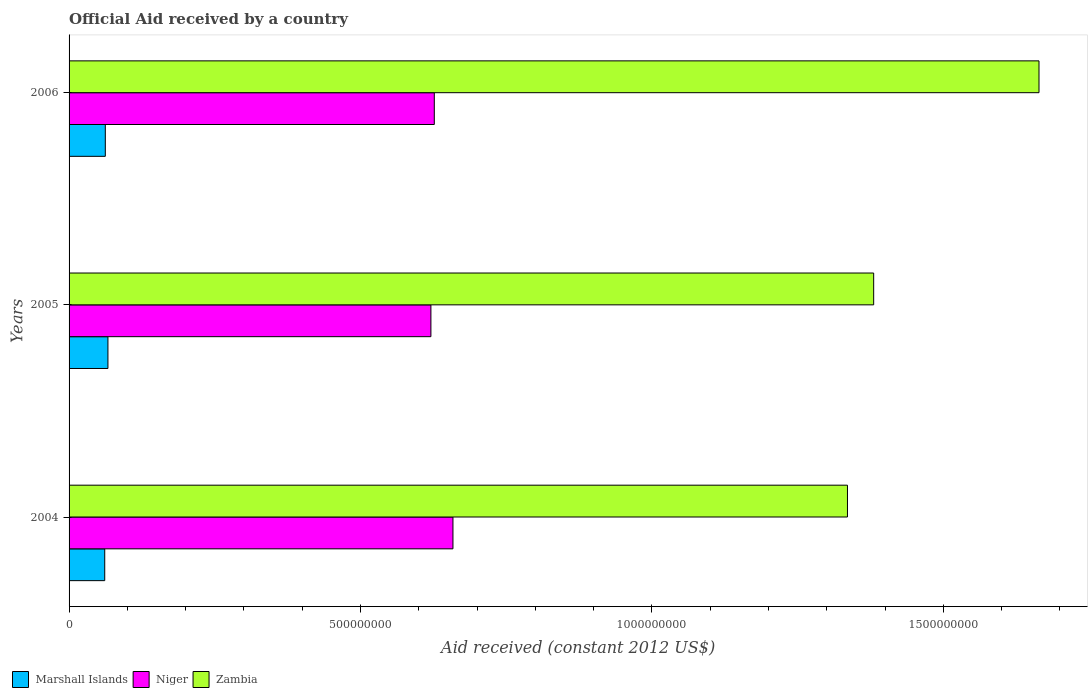How many different coloured bars are there?
Give a very brief answer. 3. How many bars are there on the 3rd tick from the top?
Provide a short and direct response. 3. How many bars are there on the 2nd tick from the bottom?
Your response must be concise. 3. What is the label of the 2nd group of bars from the top?
Make the answer very short. 2005. What is the net official aid received in Niger in 2006?
Give a very brief answer. 6.27e+08. Across all years, what is the maximum net official aid received in Marshall Islands?
Ensure brevity in your answer.  6.67e+07. Across all years, what is the minimum net official aid received in Zambia?
Give a very brief answer. 1.34e+09. In which year was the net official aid received in Niger maximum?
Make the answer very short. 2004. In which year was the net official aid received in Marshall Islands minimum?
Your response must be concise. 2004. What is the total net official aid received in Marshall Islands in the graph?
Ensure brevity in your answer.  1.90e+08. What is the difference between the net official aid received in Marshall Islands in 2004 and that in 2005?
Provide a short and direct response. -5.50e+06. What is the difference between the net official aid received in Zambia in 2004 and the net official aid received in Niger in 2005?
Ensure brevity in your answer.  7.15e+08. What is the average net official aid received in Zambia per year?
Give a very brief answer. 1.46e+09. In the year 2005, what is the difference between the net official aid received in Marshall Islands and net official aid received in Zambia?
Your answer should be very brief. -1.31e+09. What is the ratio of the net official aid received in Marshall Islands in 2004 to that in 2006?
Give a very brief answer. 0.98. Is the net official aid received in Marshall Islands in 2004 less than that in 2005?
Your response must be concise. Yes. Is the difference between the net official aid received in Marshall Islands in 2005 and 2006 greater than the difference between the net official aid received in Zambia in 2005 and 2006?
Offer a terse response. Yes. What is the difference between the highest and the second highest net official aid received in Marshall Islands?
Make the answer very short. 4.51e+06. What is the difference between the highest and the lowest net official aid received in Marshall Islands?
Provide a short and direct response. 5.50e+06. What does the 1st bar from the top in 2005 represents?
Offer a terse response. Zambia. What does the 2nd bar from the bottom in 2006 represents?
Your answer should be compact. Niger. Is it the case that in every year, the sum of the net official aid received in Niger and net official aid received in Zambia is greater than the net official aid received in Marshall Islands?
Keep it short and to the point. Yes. How many bars are there?
Ensure brevity in your answer.  9. How many years are there in the graph?
Give a very brief answer. 3. What is the difference between two consecutive major ticks on the X-axis?
Your response must be concise. 5.00e+08. Does the graph contain any zero values?
Give a very brief answer. No. How are the legend labels stacked?
Provide a short and direct response. Horizontal. What is the title of the graph?
Offer a very short reply. Official Aid received by a country. What is the label or title of the X-axis?
Your answer should be compact. Aid received (constant 2012 US$). What is the label or title of the Y-axis?
Provide a succinct answer. Years. What is the Aid received (constant 2012 US$) of Marshall Islands in 2004?
Provide a short and direct response. 6.12e+07. What is the Aid received (constant 2012 US$) of Niger in 2004?
Your answer should be very brief. 6.59e+08. What is the Aid received (constant 2012 US$) in Zambia in 2004?
Provide a succinct answer. 1.34e+09. What is the Aid received (constant 2012 US$) of Marshall Islands in 2005?
Your answer should be very brief. 6.67e+07. What is the Aid received (constant 2012 US$) in Niger in 2005?
Your response must be concise. 6.21e+08. What is the Aid received (constant 2012 US$) of Zambia in 2005?
Give a very brief answer. 1.38e+09. What is the Aid received (constant 2012 US$) in Marshall Islands in 2006?
Provide a succinct answer. 6.22e+07. What is the Aid received (constant 2012 US$) of Niger in 2006?
Make the answer very short. 6.27e+08. What is the Aid received (constant 2012 US$) in Zambia in 2006?
Provide a short and direct response. 1.66e+09. Across all years, what is the maximum Aid received (constant 2012 US$) in Marshall Islands?
Provide a succinct answer. 6.67e+07. Across all years, what is the maximum Aid received (constant 2012 US$) of Niger?
Your answer should be very brief. 6.59e+08. Across all years, what is the maximum Aid received (constant 2012 US$) in Zambia?
Provide a short and direct response. 1.66e+09. Across all years, what is the minimum Aid received (constant 2012 US$) of Marshall Islands?
Provide a short and direct response. 6.12e+07. Across all years, what is the minimum Aid received (constant 2012 US$) in Niger?
Give a very brief answer. 6.21e+08. Across all years, what is the minimum Aid received (constant 2012 US$) of Zambia?
Offer a terse response. 1.34e+09. What is the total Aid received (constant 2012 US$) in Marshall Islands in the graph?
Ensure brevity in your answer.  1.90e+08. What is the total Aid received (constant 2012 US$) in Niger in the graph?
Make the answer very short. 1.91e+09. What is the total Aid received (constant 2012 US$) of Zambia in the graph?
Provide a short and direct response. 4.38e+09. What is the difference between the Aid received (constant 2012 US$) of Marshall Islands in 2004 and that in 2005?
Your answer should be compact. -5.50e+06. What is the difference between the Aid received (constant 2012 US$) of Niger in 2004 and that in 2005?
Provide a short and direct response. 3.78e+07. What is the difference between the Aid received (constant 2012 US$) of Zambia in 2004 and that in 2005?
Your answer should be compact. -4.50e+07. What is the difference between the Aid received (constant 2012 US$) of Marshall Islands in 2004 and that in 2006?
Your answer should be compact. -9.90e+05. What is the difference between the Aid received (constant 2012 US$) in Niger in 2004 and that in 2006?
Your answer should be very brief. 3.20e+07. What is the difference between the Aid received (constant 2012 US$) in Zambia in 2004 and that in 2006?
Give a very brief answer. -3.29e+08. What is the difference between the Aid received (constant 2012 US$) of Marshall Islands in 2005 and that in 2006?
Offer a terse response. 4.51e+06. What is the difference between the Aid received (constant 2012 US$) of Niger in 2005 and that in 2006?
Provide a short and direct response. -5.81e+06. What is the difference between the Aid received (constant 2012 US$) of Zambia in 2005 and that in 2006?
Offer a terse response. -2.84e+08. What is the difference between the Aid received (constant 2012 US$) of Marshall Islands in 2004 and the Aid received (constant 2012 US$) of Niger in 2005?
Your response must be concise. -5.60e+08. What is the difference between the Aid received (constant 2012 US$) in Marshall Islands in 2004 and the Aid received (constant 2012 US$) in Zambia in 2005?
Keep it short and to the point. -1.32e+09. What is the difference between the Aid received (constant 2012 US$) of Niger in 2004 and the Aid received (constant 2012 US$) of Zambia in 2005?
Make the answer very short. -7.22e+08. What is the difference between the Aid received (constant 2012 US$) in Marshall Islands in 2004 and the Aid received (constant 2012 US$) in Niger in 2006?
Your response must be concise. -5.65e+08. What is the difference between the Aid received (constant 2012 US$) in Marshall Islands in 2004 and the Aid received (constant 2012 US$) in Zambia in 2006?
Provide a short and direct response. -1.60e+09. What is the difference between the Aid received (constant 2012 US$) of Niger in 2004 and the Aid received (constant 2012 US$) of Zambia in 2006?
Make the answer very short. -1.01e+09. What is the difference between the Aid received (constant 2012 US$) in Marshall Islands in 2005 and the Aid received (constant 2012 US$) in Niger in 2006?
Your response must be concise. -5.60e+08. What is the difference between the Aid received (constant 2012 US$) of Marshall Islands in 2005 and the Aid received (constant 2012 US$) of Zambia in 2006?
Your answer should be very brief. -1.60e+09. What is the difference between the Aid received (constant 2012 US$) of Niger in 2005 and the Aid received (constant 2012 US$) of Zambia in 2006?
Provide a short and direct response. -1.04e+09. What is the average Aid received (constant 2012 US$) in Marshall Islands per year?
Give a very brief answer. 6.34e+07. What is the average Aid received (constant 2012 US$) of Niger per year?
Keep it short and to the point. 6.35e+08. What is the average Aid received (constant 2012 US$) of Zambia per year?
Give a very brief answer. 1.46e+09. In the year 2004, what is the difference between the Aid received (constant 2012 US$) in Marshall Islands and Aid received (constant 2012 US$) in Niger?
Provide a short and direct response. -5.97e+08. In the year 2004, what is the difference between the Aid received (constant 2012 US$) in Marshall Islands and Aid received (constant 2012 US$) in Zambia?
Offer a terse response. -1.27e+09. In the year 2004, what is the difference between the Aid received (constant 2012 US$) of Niger and Aid received (constant 2012 US$) of Zambia?
Ensure brevity in your answer.  -6.77e+08. In the year 2005, what is the difference between the Aid received (constant 2012 US$) of Marshall Islands and Aid received (constant 2012 US$) of Niger?
Offer a very short reply. -5.54e+08. In the year 2005, what is the difference between the Aid received (constant 2012 US$) in Marshall Islands and Aid received (constant 2012 US$) in Zambia?
Give a very brief answer. -1.31e+09. In the year 2005, what is the difference between the Aid received (constant 2012 US$) of Niger and Aid received (constant 2012 US$) of Zambia?
Your answer should be very brief. -7.60e+08. In the year 2006, what is the difference between the Aid received (constant 2012 US$) in Marshall Islands and Aid received (constant 2012 US$) in Niger?
Give a very brief answer. -5.64e+08. In the year 2006, what is the difference between the Aid received (constant 2012 US$) of Marshall Islands and Aid received (constant 2012 US$) of Zambia?
Offer a very short reply. -1.60e+09. In the year 2006, what is the difference between the Aid received (constant 2012 US$) in Niger and Aid received (constant 2012 US$) in Zambia?
Your answer should be very brief. -1.04e+09. What is the ratio of the Aid received (constant 2012 US$) in Marshall Islands in 2004 to that in 2005?
Provide a short and direct response. 0.92. What is the ratio of the Aid received (constant 2012 US$) of Niger in 2004 to that in 2005?
Provide a short and direct response. 1.06. What is the ratio of the Aid received (constant 2012 US$) in Zambia in 2004 to that in 2005?
Offer a terse response. 0.97. What is the ratio of the Aid received (constant 2012 US$) in Marshall Islands in 2004 to that in 2006?
Offer a very short reply. 0.98. What is the ratio of the Aid received (constant 2012 US$) of Niger in 2004 to that in 2006?
Provide a short and direct response. 1.05. What is the ratio of the Aid received (constant 2012 US$) in Zambia in 2004 to that in 2006?
Your answer should be very brief. 0.8. What is the ratio of the Aid received (constant 2012 US$) in Marshall Islands in 2005 to that in 2006?
Your answer should be compact. 1.07. What is the ratio of the Aid received (constant 2012 US$) of Niger in 2005 to that in 2006?
Ensure brevity in your answer.  0.99. What is the ratio of the Aid received (constant 2012 US$) in Zambia in 2005 to that in 2006?
Make the answer very short. 0.83. What is the difference between the highest and the second highest Aid received (constant 2012 US$) of Marshall Islands?
Make the answer very short. 4.51e+06. What is the difference between the highest and the second highest Aid received (constant 2012 US$) of Niger?
Make the answer very short. 3.20e+07. What is the difference between the highest and the second highest Aid received (constant 2012 US$) in Zambia?
Your answer should be very brief. 2.84e+08. What is the difference between the highest and the lowest Aid received (constant 2012 US$) of Marshall Islands?
Give a very brief answer. 5.50e+06. What is the difference between the highest and the lowest Aid received (constant 2012 US$) of Niger?
Provide a short and direct response. 3.78e+07. What is the difference between the highest and the lowest Aid received (constant 2012 US$) of Zambia?
Your answer should be compact. 3.29e+08. 